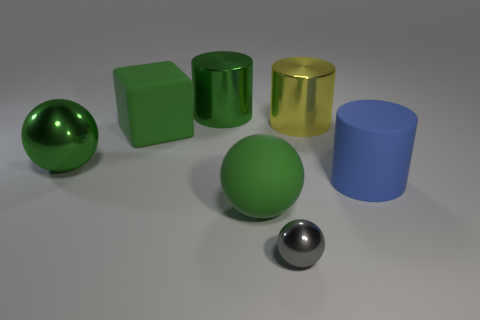Could you estimate the size of the objects relative to each other? While we can't determine the absolute size without a reference object, relatively speaking, the green cube and the large yellow cylinder seem to be the largest objects. The spheres are smaller, with one substantially larger than the other, which is quite petite in comparison. The blue cylinder looks to be similar in height to the smaller sphere but with a wider diameter. 